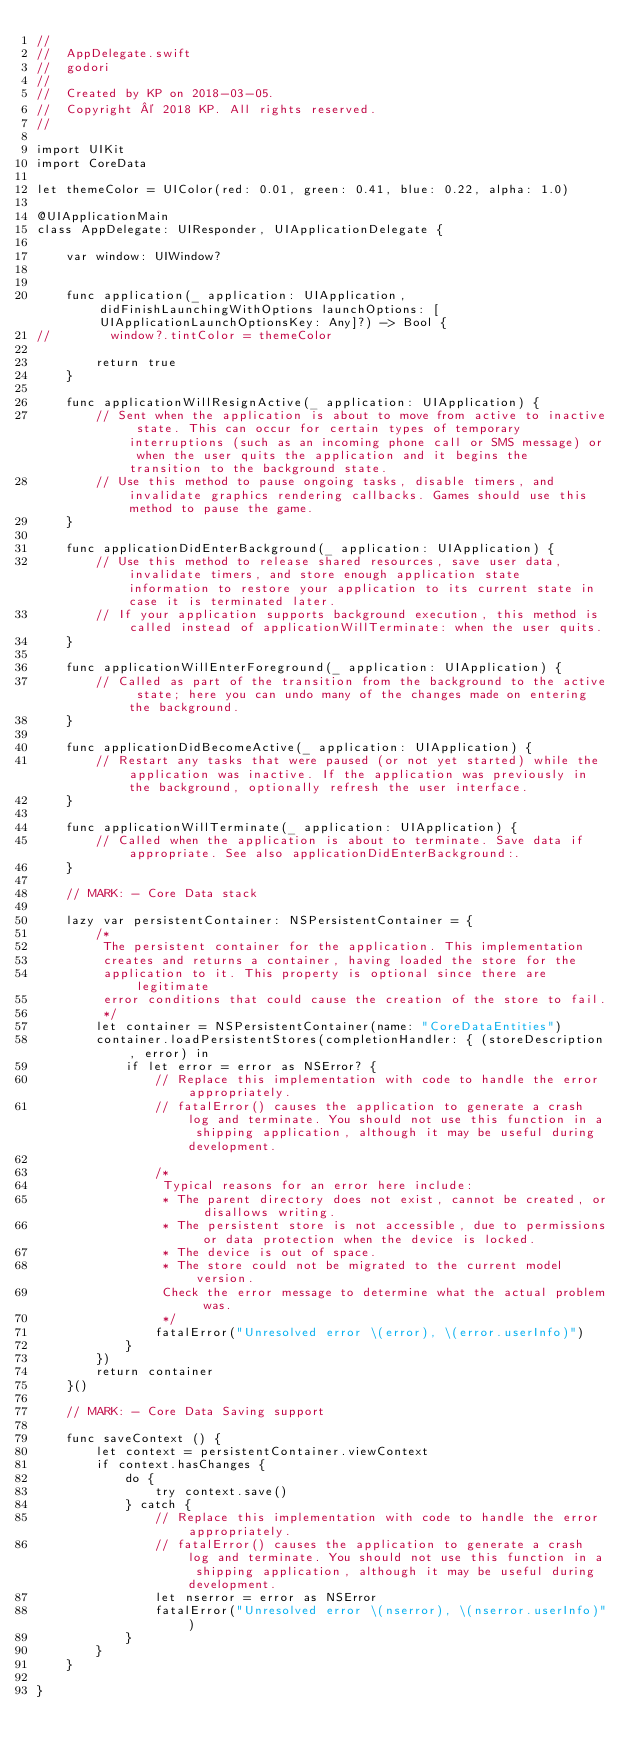<code> <loc_0><loc_0><loc_500><loc_500><_Swift_>//
//  AppDelegate.swift
//  godori
//
//  Created by KP on 2018-03-05.
//  Copyright © 2018 KP. All rights reserved.
//

import UIKit
import CoreData

let themeColor = UIColor(red: 0.01, green: 0.41, blue: 0.22, alpha: 1.0)

@UIApplicationMain
class AppDelegate: UIResponder, UIApplicationDelegate {

    var window: UIWindow?


    func application(_ application: UIApplication, didFinishLaunchingWithOptions launchOptions: [UIApplicationLaunchOptionsKey: Any]?) -> Bool {
//        window?.tintColor = themeColor
        
        return true
    }

    func applicationWillResignActive(_ application: UIApplication) {
        // Sent when the application is about to move from active to inactive state. This can occur for certain types of temporary interruptions (such as an incoming phone call or SMS message) or when the user quits the application and it begins the transition to the background state.
        // Use this method to pause ongoing tasks, disable timers, and invalidate graphics rendering callbacks. Games should use this method to pause the game.
    }

    func applicationDidEnterBackground(_ application: UIApplication) {
        // Use this method to release shared resources, save user data, invalidate timers, and store enough application state information to restore your application to its current state in case it is terminated later.
        // If your application supports background execution, this method is called instead of applicationWillTerminate: when the user quits.
    }

    func applicationWillEnterForeground(_ application: UIApplication) {
        // Called as part of the transition from the background to the active state; here you can undo many of the changes made on entering the background.
    }

    func applicationDidBecomeActive(_ application: UIApplication) {
        // Restart any tasks that were paused (or not yet started) while the application was inactive. If the application was previously in the background, optionally refresh the user interface.
    }

    func applicationWillTerminate(_ application: UIApplication) {
        // Called when the application is about to terminate. Save data if appropriate. See also applicationDidEnterBackground:.
    }
    
    // MARK: - Core Data stack
    
    lazy var persistentContainer: NSPersistentContainer = {
        /*
         The persistent container for the application. This implementation
         creates and returns a container, having loaded the store for the
         application to it. This property is optional since there are legitimate
         error conditions that could cause the creation of the store to fail.
         */
        let container = NSPersistentContainer(name: "CoreDataEntities")
        container.loadPersistentStores(completionHandler: { (storeDescription, error) in
            if let error = error as NSError? {
                // Replace this implementation with code to handle the error appropriately.
                // fatalError() causes the application to generate a crash log and terminate. You should not use this function in a shipping application, although it may be useful during development.
                
                /*
                 Typical reasons for an error here include:
                 * The parent directory does not exist, cannot be created, or disallows writing.
                 * The persistent store is not accessible, due to permissions or data protection when the device is locked.
                 * The device is out of space.
                 * The store could not be migrated to the current model version.
                 Check the error message to determine what the actual problem was.
                 */
                fatalError("Unresolved error \(error), \(error.userInfo)")
            }
        })
        return container
    }()
    
    // MARK: - Core Data Saving support
    
    func saveContext () {
        let context = persistentContainer.viewContext
        if context.hasChanges {
            do {
                try context.save()
            } catch {
                // Replace this implementation with code to handle the error appropriately.
                // fatalError() causes the application to generate a crash log and terminate. You should not use this function in a shipping application, although it may be useful during development.
                let nserror = error as NSError
                fatalError("Unresolved error \(nserror), \(nserror.userInfo)")
            }
        }
    }

}

</code> 